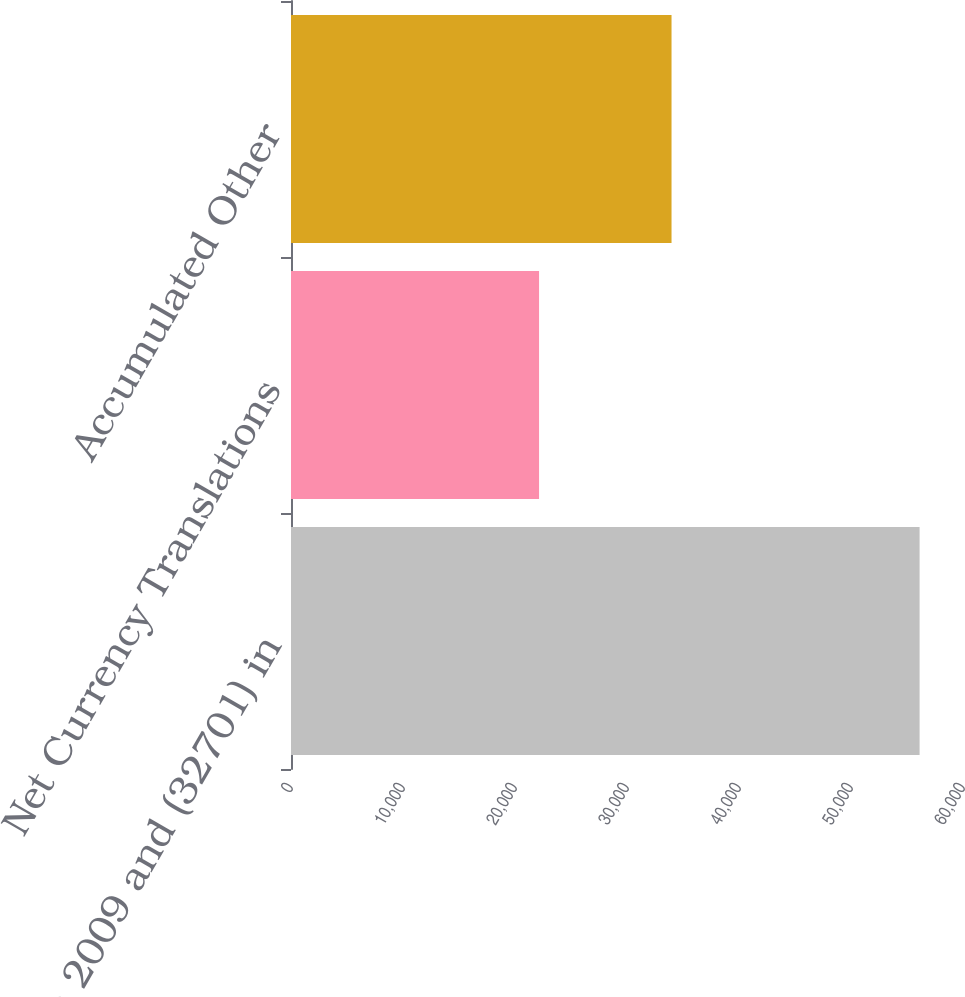<chart> <loc_0><loc_0><loc_500><loc_500><bar_chart><fcel>(35777) in 2009 and (32701) in<fcel>Net Currency Translations<fcel>Accumulated Other<nl><fcel>56124<fcel>22148<fcel>33976<nl></chart> 